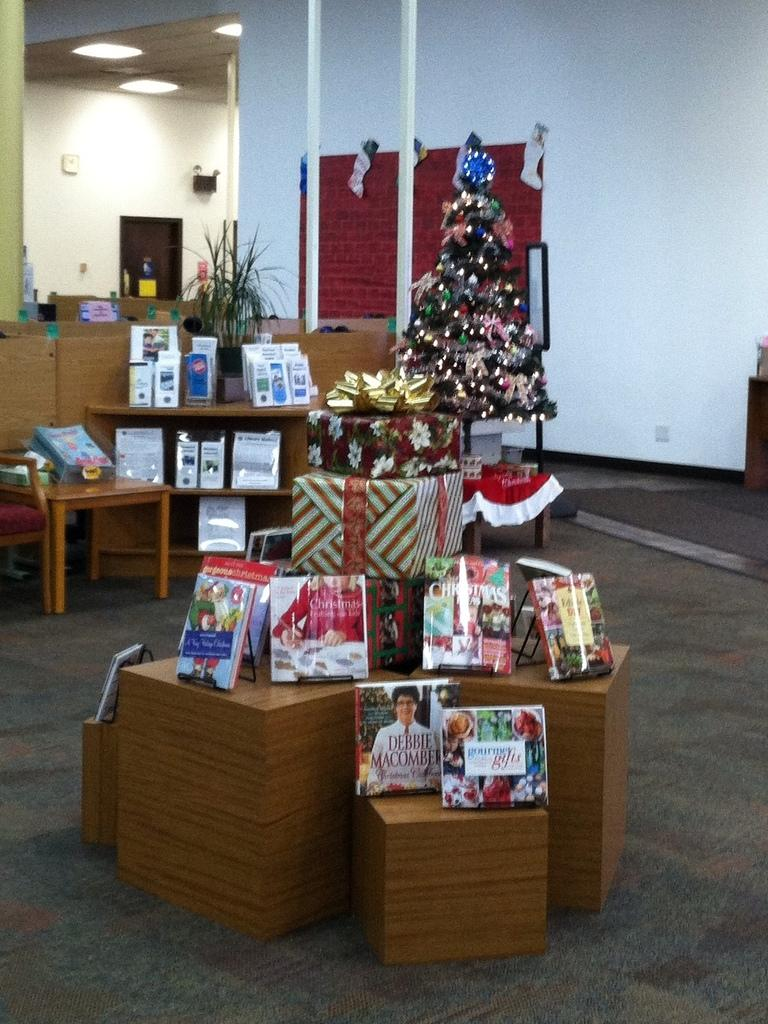What type of tree is in the image? There is a Christmas tree in the image. What else can be seen near the Christmas tree? There are packed gifts in the image. What is on the table in the image? There is a plant on the table in the image. What type of battle is taking place near the Christmas tree in the image? There is no battle present in the image; it features a Christmas tree, packed gifts, and a plant on the table. What muscle is being exercised by the plant in the image? The plant in the image is not exercising any muscles, as it is a non-living object. 